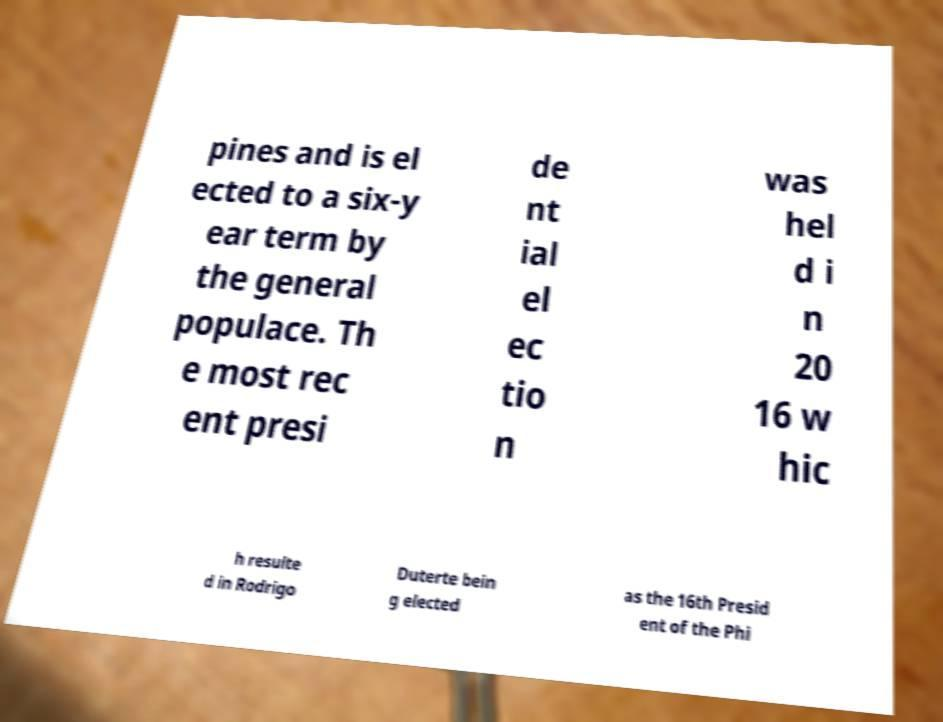I need the written content from this picture converted into text. Can you do that? pines and is el ected to a six-y ear term by the general populace. Th e most rec ent presi de nt ial el ec tio n was hel d i n 20 16 w hic h resulte d in Rodrigo Duterte bein g elected as the 16th Presid ent of the Phi 